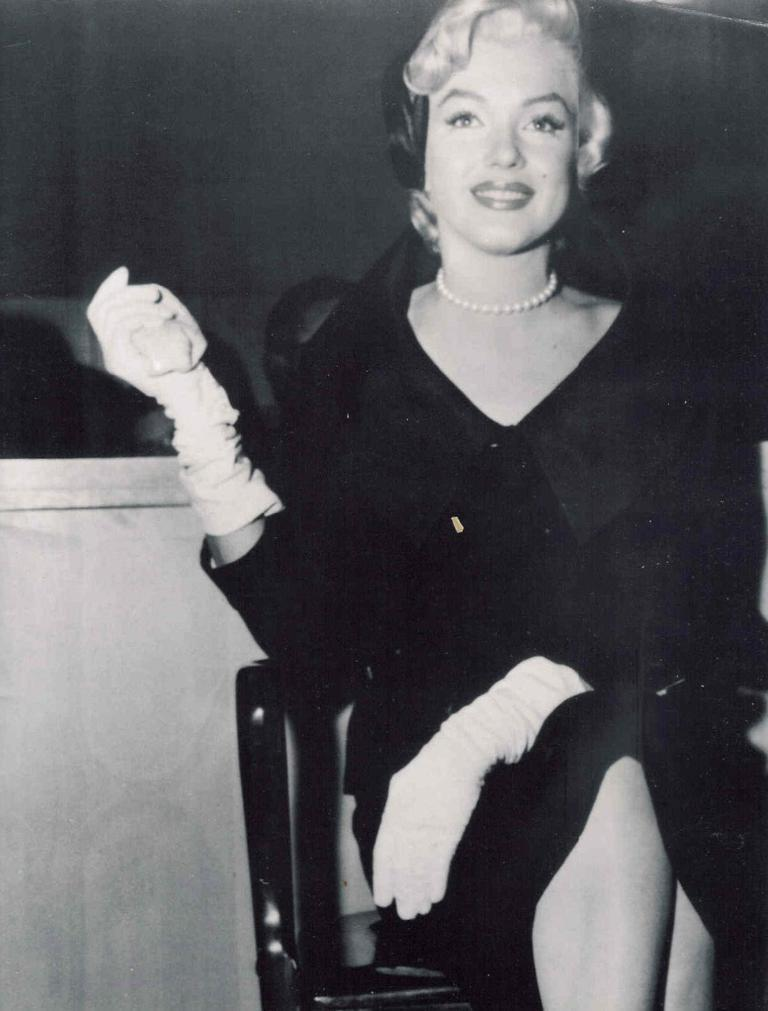What is the color scheme of the photo? The photo is black and white. Who is in the photo? There is a woman in the photo. What is the woman doing in the photo? The woman is sitting on a chair. What is the woman wearing in the photo? The woman is wearing a black dress. What is the appearance of the woman's hair in the photo? The woman has short hair. What is the woman's facial expression in the photo? The woman is smiling. What type of mint can be seen growing in the background of the photo? There is no mint visible in the photo; it is a black and white image of a woman sitting on a chair. 